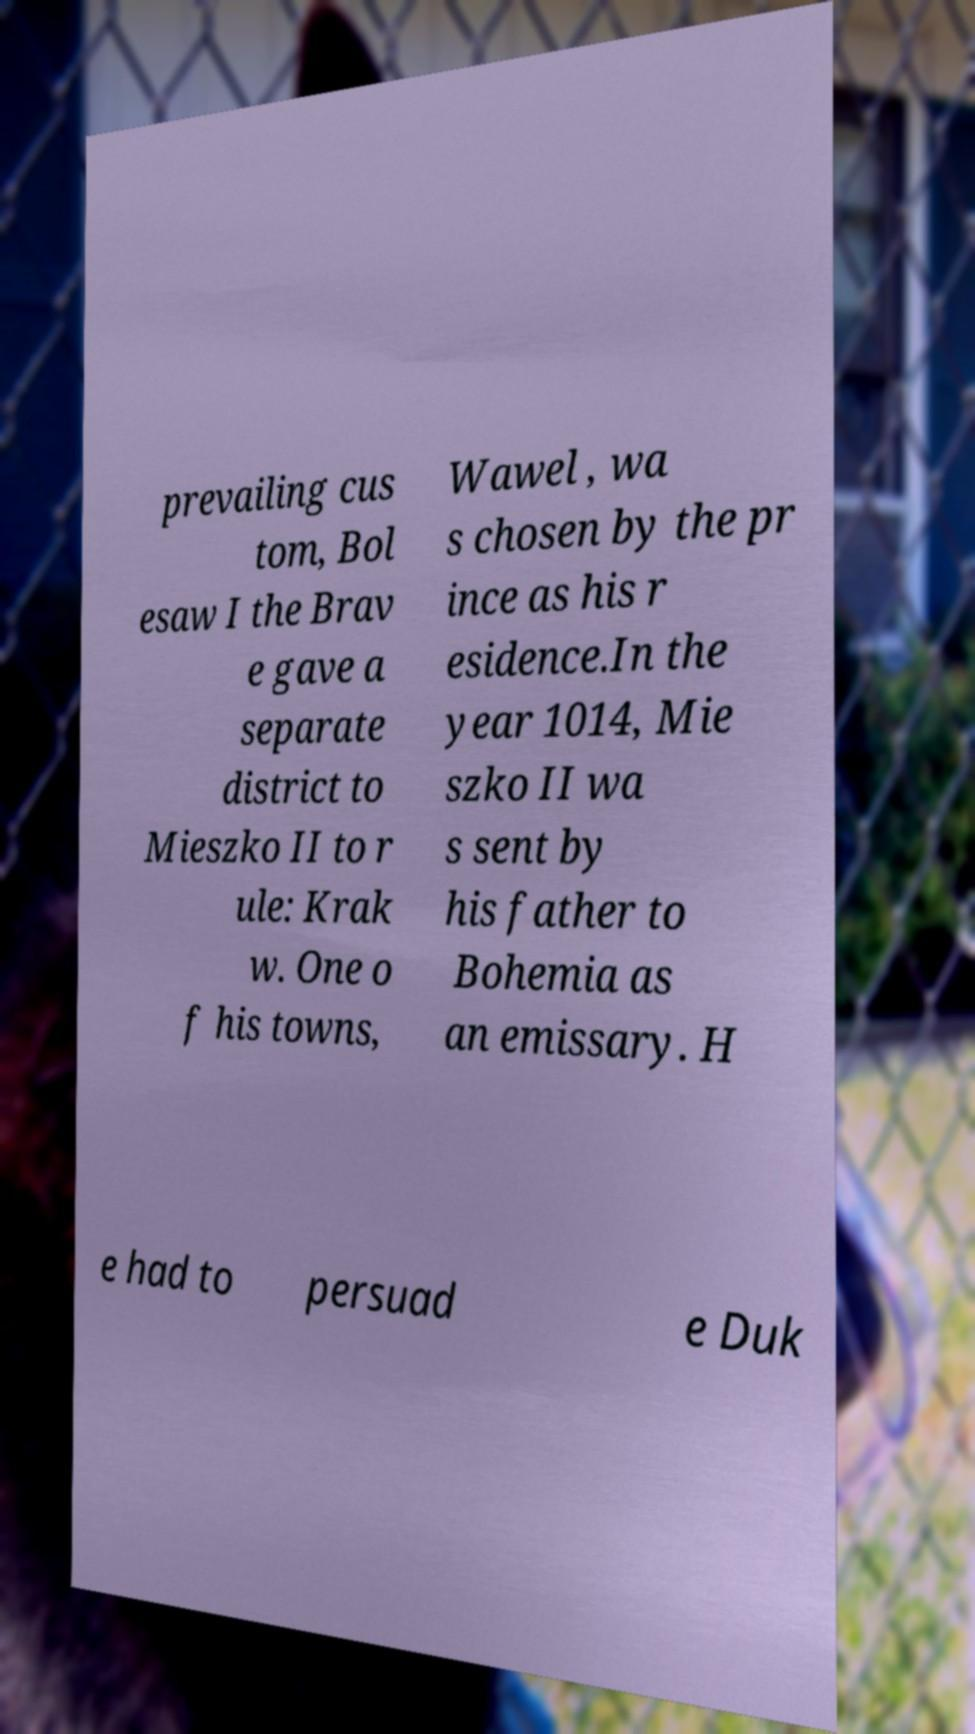What messages or text are displayed in this image? I need them in a readable, typed format. prevailing cus tom, Bol esaw I the Brav e gave a separate district to Mieszko II to r ule: Krak w. One o f his towns, Wawel , wa s chosen by the pr ince as his r esidence.In the year 1014, Mie szko II wa s sent by his father to Bohemia as an emissary. H e had to persuad e Duk 